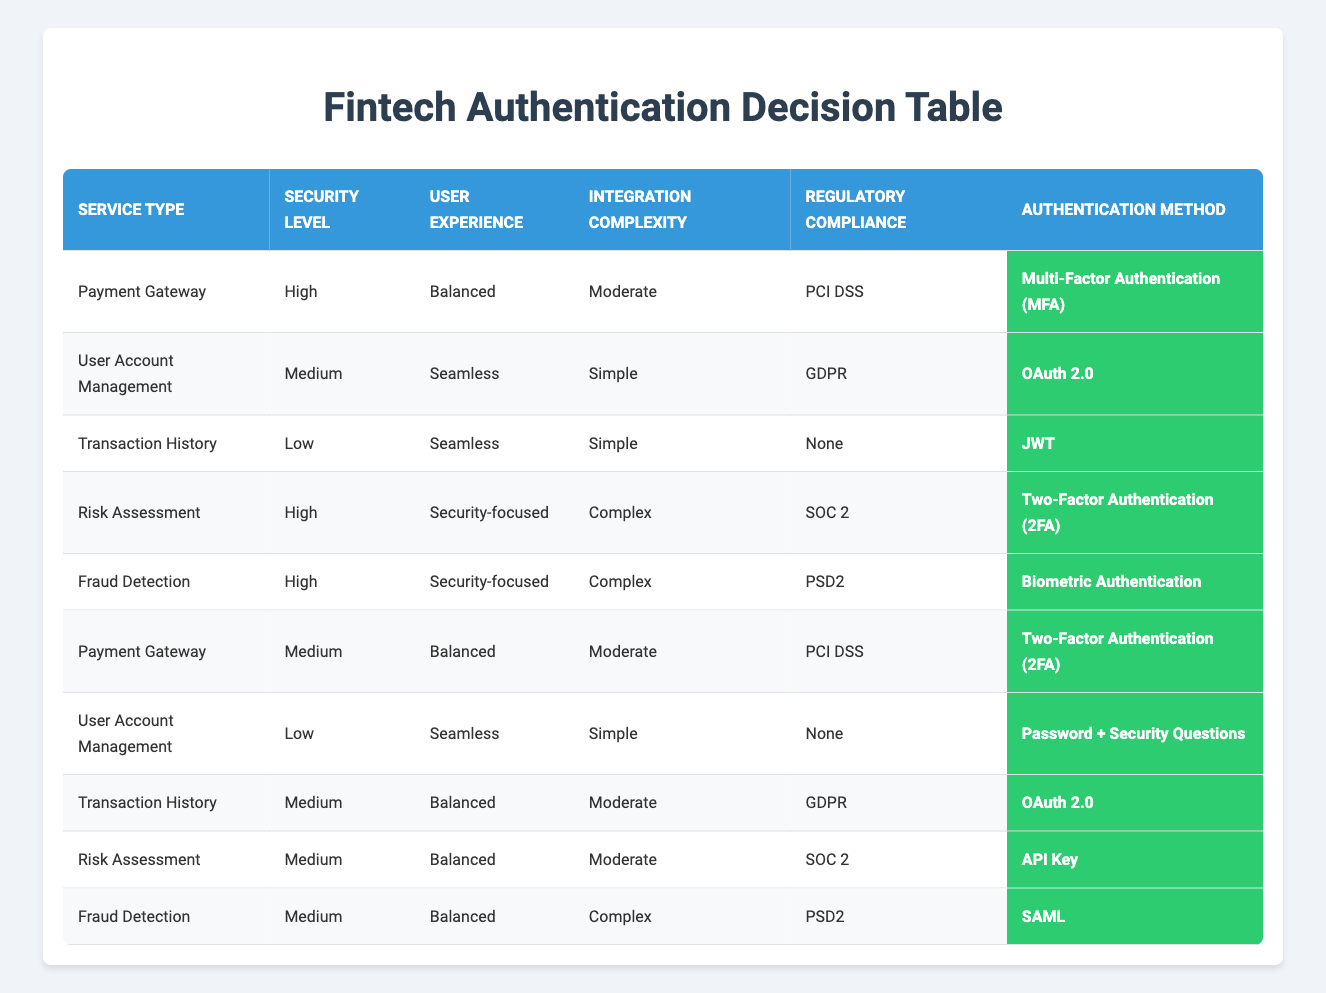What authentication method is recommended for Payment Gateway with High security and Balanced user experience? The row corresponding to Payment Gateway, High security, and Balanced user experience indicates that the recommended authentication method is Multi-Factor Authentication (MFA).
Answer: Multi-Factor Authentication (MFA) Which service requires Biometric Authentication? The row for Fraud Detection with High security and Security-focused user experience specifies that Biometric Authentication is the recommended method.
Answer: Fraud Detection Is API Key suggested for Risk Assessment at Medium security? Looking at the table, the row for Risk Assessment with Medium security indicates that API Key is the recommended method.
Answer: Yes What authentication methods are used for User Account Management with Low security? There are two rows for User Account Management with Low security: the recommendation is Password + Security Questions, indicating it is the only method listed for this scenario.
Answer: Password + Security Questions How many authentication methods are suggested for Transaction History? There are three rows concerning Transaction History: it has different recommendations depending on the conditions. The listed methods are JWT for Low security, OAuth 2.0 for Medium security, making a total of two unique methods suggested for different criteria.
Answer: 2 Is Two-Factor Authentication used for services other than Payment Gateway? In the table, Two-Factor Authentication is recommended not only for Payment Gateway but also for Risk Assessment. By checking both rows, we see that it applies to Risk Assessment with High security as well.
Answer: Yes What is the common aspect between authentication methods for both Fraud Detection and Risk Assessment with High security? Evaluating both rows, we can see that they have Security-focused user experience as a common aspect. Fraud Detection uses Biometric Authentication while Risk Assessment uses Two-Factor Authentication (2FA).
Answer: Security-focused user experience Which services require seamless user experience while having Low security? The table reveals that only Transaction History is categorized with Low security and Seamless user experience. It is the only one fitting this criterion, resulting in zero additional services matching these two conditions.
Answer: Transaction History How many services recommend Two-Factor Authentication? There are two services listed that recommend Two-Factor Authentication: Payment Gateway (both Medium and High security scenarios) and Risk Assessment (High security). When summed, this results in three recommendations for Two-Factor Authentication.
Answer: 3 